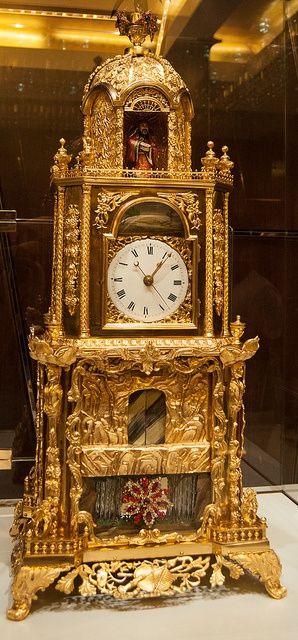Describe the objects in this image and their specific colors. I can see a clock in olive, tan, and beige tones in this image. 